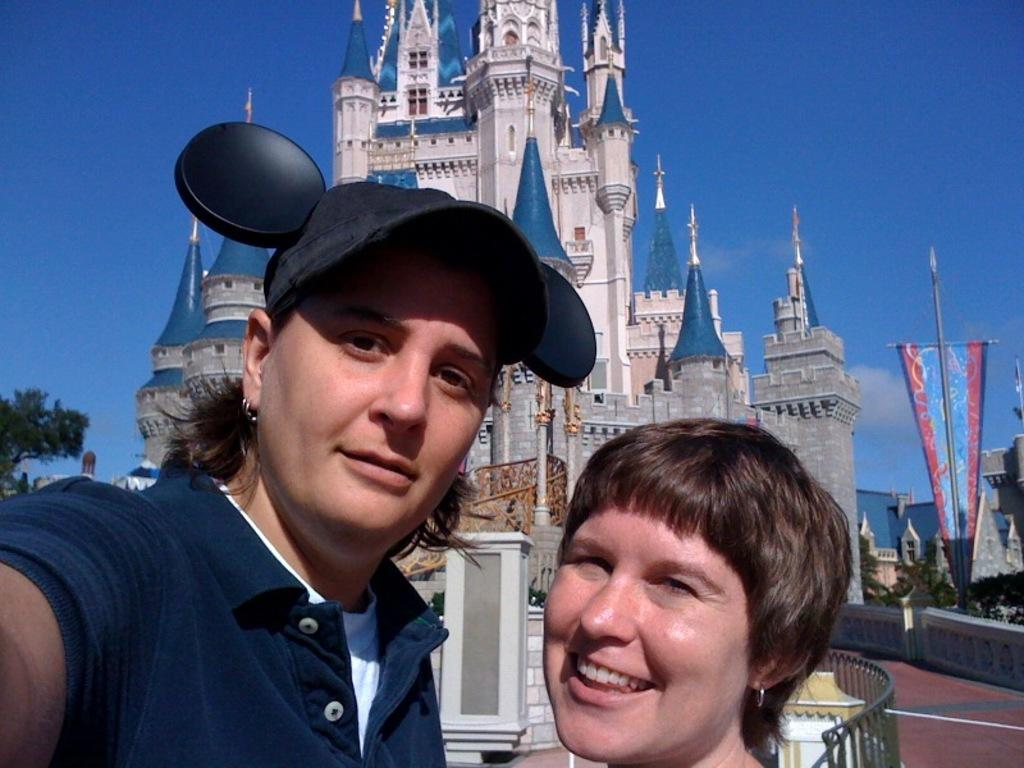How many women are present in the image? There are two women in the image. What can be seen in the background of the image? There is a building and trees visible in the background of the image. What type of quiet cent is visible in the image? There is no cent present in the image, and the image does not convey any information about the level of noise or quietness. 